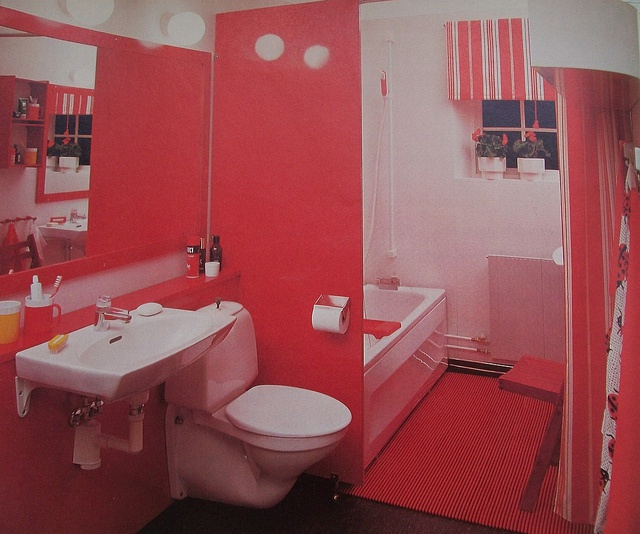Describe the objects in this image and their specific colors. I can see toilet in gray, maroon, brown, and darkgray tones, sink in gray, darkgray, brown, and maroon tones, chair in gray, maroon, and brown tones, potted plant in gray, darkgray, brown, and black tones, and potted plant in gray, darkgray, black, and brown tones in this image. 